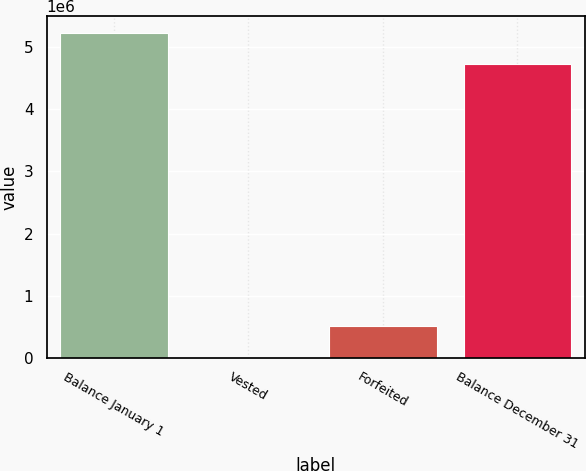Convert chart to OTSL. <chart><loc_0><loc_0><loc_500><loc_500><bar_chart><fcel>Balance January 1<fcel>Vested<fcel>Forfeited<fcel>Balance December 31<nl><fcel>5.23715e+06<fcel>6000<fcel>510150<fcel>4.733e+06<nl></chart> 